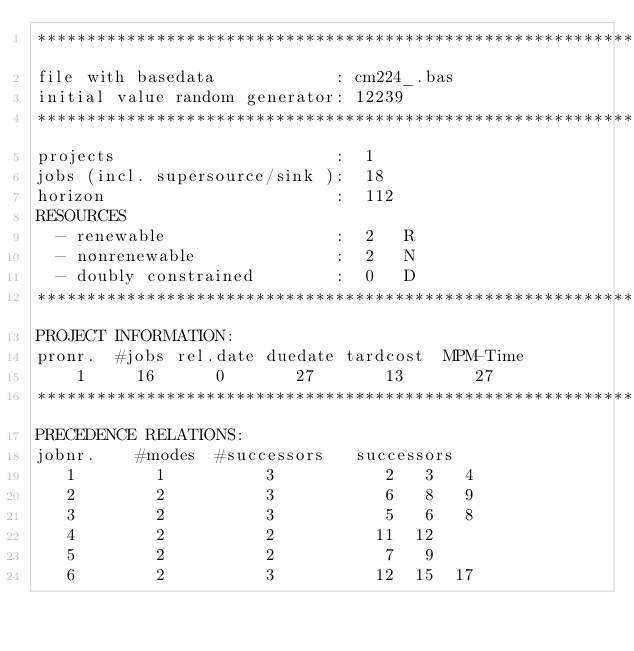Convert code to text. <code><loc_0><loc_0><loc_500><loc_500><_ObjectiveC_>************************************************************************
file with basedata            : cm224_.bas
initial value random generator: 12239
************************************************************************
projects                      :  1
jobs (incl. supersource/sink ):  18
horizon                       :  112
RESOURCES
  - renewable                 :  2   R
  - nonrenewable              :  2   N
  - doubly constrained        :  0   D
************************************************************************
PROJECT INFORMATION:
pronr.  #jobs rel.date duedate tardcost  MPM-Time
    1     16      0       27       13       27
************************************************************************
PRECEDENCE RELATIONS:
jobnr.    #modes  #successors   successors
   1        1          3           2   3   4
   2        2          3           6   8   9
   3        2          3           5   6   8
   4        2          2          11  12
   5        2          2           7   9
   6        2          3          12  15  17</code> 